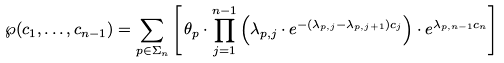Convert formula to latex. <formula><loc_0><loc_0><loc_500><loc_500>\wp ( c _ { 1 } , \dots , c _ { n - 1 } ) = \sum _ { { p } \in \Sigma _ { n } } \left [ \, \theta _ { p } \cdot \prod _ { j = 1 } ^ { n - 1 } \left ( \lambda _ { { p } , j } \cdot e ^ { - ( \lambda _ { { p } , j } - \lambda _ { { p } , j + 1 } ) c _ { j } } \right ) \cdot e ^ { \lambda _ { p , n - 1 } c _ { n } } \right ] \,</formula> 